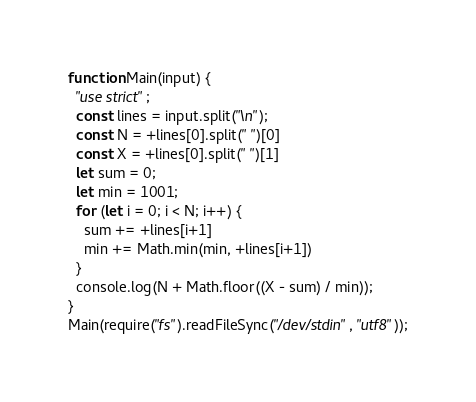<code> <loc_0><loc_0><loc_500><loc_500><_JavaScript_>function Main(input) {
  "use strict";
  const lines = input.split("\n");
  const N = +lines[0].split(" ")[0]
  const X = +lines[0].split(" ")[1]
  let sum = 0;
  let min = 1001;
  for (let i = 0; i < N; i++) {
    sum += +lines[i+1]
    min += Math.min(min, +lines[i+1])
  }
  console.log(N + Math.floor((X - sum) / min));
}
Main(require("fs").readFileSync("/dev/stdin", "utf8"));</code> 